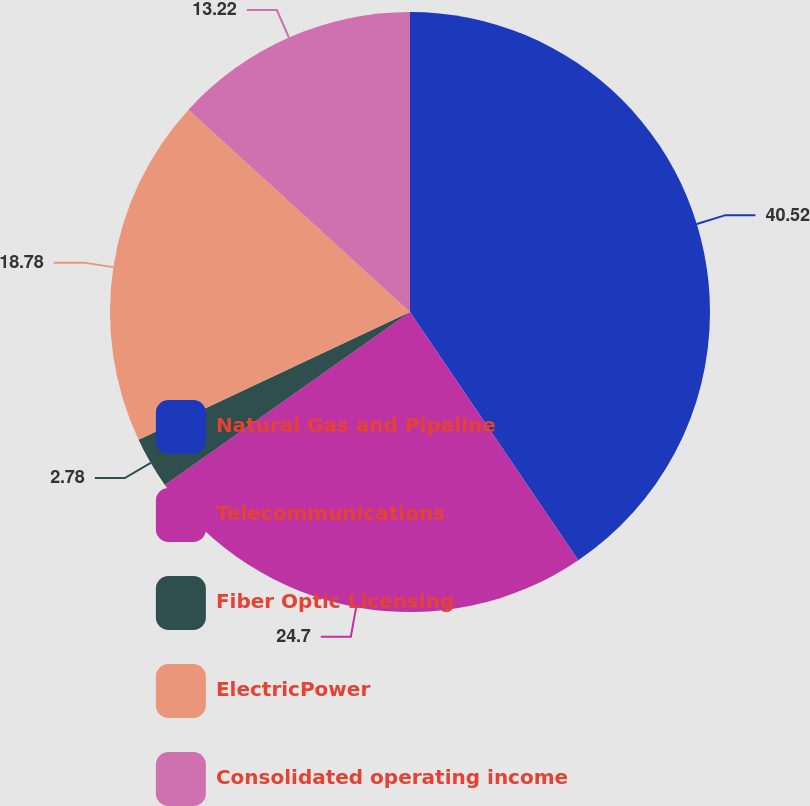<chart> <loc_0><loc_0><loc_500><loc_500><pie_chart><fcel>Natural Gas and Pipeline<fcel>Telecommunications<fcel>Fiber Optic Licensing<fcel>ElectricPower<fcel>Consolidated operating income<nl><fcel>40.52%<fcel>24.7%<fcel>2.78%<fcel>18.78%<fcel>13.22%<nl></chart> 